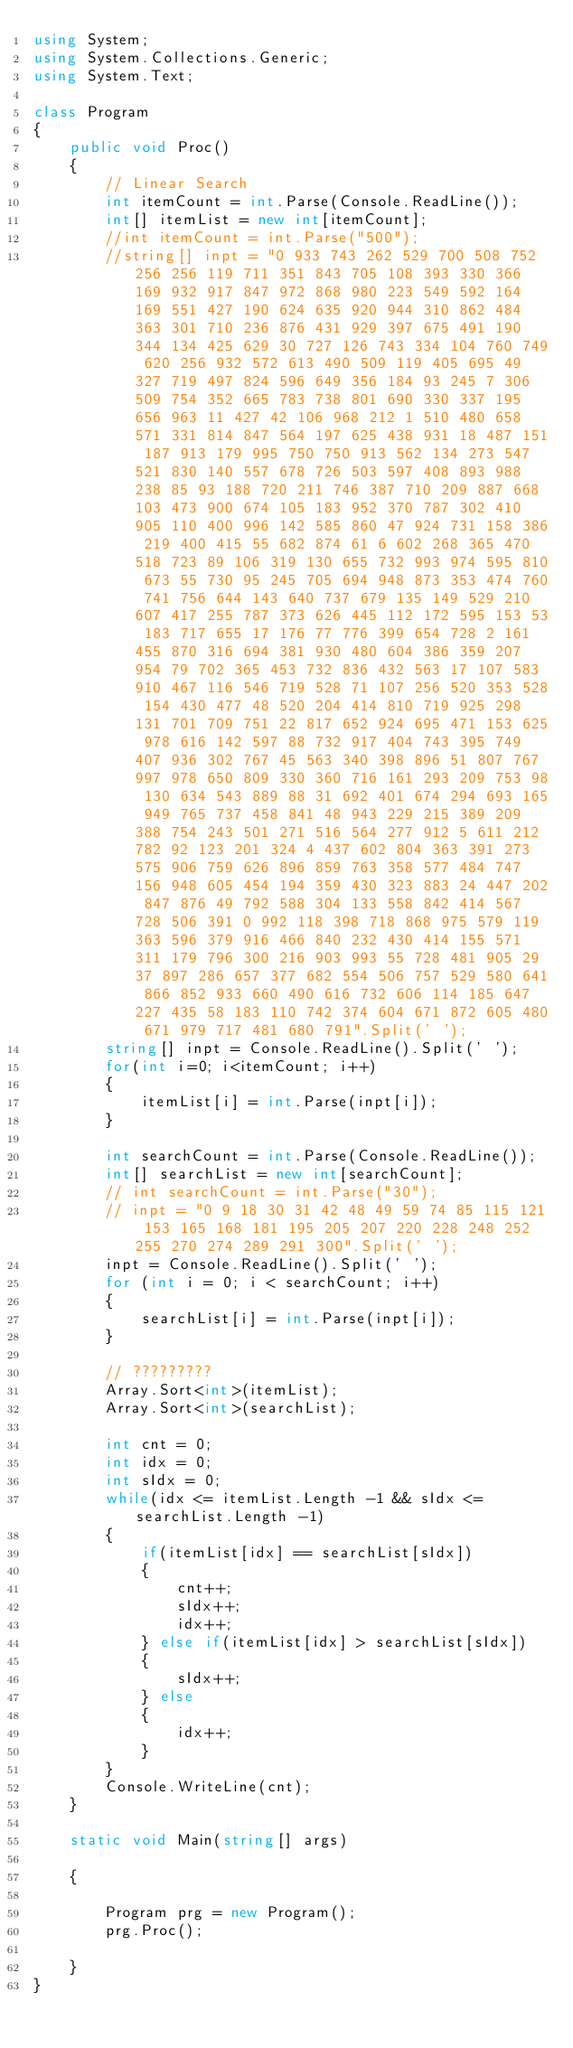Convert code to text. <code><loc_0><loc_0><loc_500><loc_500><_C#_>using System;
using System.Collections.Generic;
using System.Text;

class Program
{
    public void Proc()
    {
        // Linear Search
        int itemCount = int.Parse(Console.ReadLine());
        int[] itemList = new int[itemCount];
        //int itemCount = int.Parse("500");
        //string[] inpt = "0 933 743 262 529 700 508 752 256 256 119 711 351 843 705 108 393 330 366 169 932 917 847 972 868 980 223 549 592 164 169 551 427 190 624 635 920 944 310 862 484 363 301 710 236 876 431 929 397 675 491 190 344 134 425 629 30 727 126 743 334 104 760 749 620 256 932 572 613 490 509 119 405 695 49 327 719 497 824 596 649 356 184 93 245 7 306 509 754 352 665 783 738 801 690 330 337 195 656 963 11 427 42 106 968 212 1 510 480 658 571 331 814 847 564 197 625 438 931 18 487 151 187 913 179 995 750 750 913 562 134 273 547 521 830 140 557 678 726 503 597 408 893 988 238 85 93 188 720 211 746 387 710 209 887 668 103 473 900 674 105 183 952 370 787 302 410 905 110 400 996 142 585 860 47 924 731 158 386 219 400 415 55 682 874 61 6 602 268 365 470 518 723 89 106 319 130 655 732 993 974 595 810 673 55 730 95 245 705 694 948 873 353 474 760 741 756 644 143 640 737 679 135 149 529 210 607 417 255 787 373 626 445 112 172 595 153 53 183 717 655 17 176 77 776 399 654 728 2 161 455 870 316 694 381 930 480 604 386 359 207 954 79 702 365 453 732 836 432 563 17 107 583 910 467 116 546 719 528 71 107 256 520 353 528 154 430 477 48 520 204 414 810 719 925 298 131 701 709 751 22 817 652 924 695 471 153 625 978 616 142 597 88 732 917 404 743 395 749 407 936 302 767 45 563 340 398 896 51 807 767 997 978 650 809 330 360 716 161 293 209 753 98 130 634 543 889 88 31 692 401 674 294 693 165 949 765 737 458 841 48 943 229 215 389 209 388 754 243 501 271 516 564 277 912 5 611 212 782 92 123 201 324 4 437 602 804 363 391 273 575 906 759 626 896 859 763 358 577 484 747 156 948 605 454 194 359 430 323 883 24 447 202 847 876 49 792 588 304 133 558 842 414 567 728 506 391 0 992 118 398 718 868 975 579 119 363 596 379 916 466 840 232 430 414 155 571 311 179 796 300 216 903 993 55 728 481 905 29 37 897 286 657 377 682 554 506 757 529 580 641 866 852 933 660 490 616 732 606 114 185 647 227 435 58 183 110 742 374 604 671 872 605 480 671 979 717 481 680 791".Split(' ');
        string[] inpt = Console.ReadLine().Split(' ');
        for(int i=0; i<itemCount; i++)
        {
            itemList[i] = int.Parse(inpt[i]);
        }

        int searchCount = int.Parse(Console.ReadLine());
        int[] searchList = new int[searchCount];
        // int searchCount = int.Parse("30");
        // inpt = "0 9 18 30 31 42 48 49 59 74 85 115 121 153 165 168 181 195 205 207 220 228 248 252 255 270 274 289 291 300".Split(' ');
        inpt = Console.ReadLine().Split(' ');
        for (int i = 0; i < searchCount; i++)
        {
            searchList[i] = int.Parse(inpt[i]);
        }

        // ?????????
        Array.Sort<int>(itemList);
        Array.Sort<int>(searchList);

        int cnt = 0;
        int idx = 0;
        int sIdx = 0;
        while(idx <= itemList.Length -1 && sIdx <= searchList.Length -1)
        {
            if(itemList[idx] == searchList[sIdx])
            {
                cnt++;
                sIdx++;
                idx++;
            } else if(itemList[idx] > searchList[sIdx])
            {
                sIdx++;
            } else
            {
                idx++;
            }
        }
        Console.WriteLine(cnt);
    }

    static void Main(string[] args)

    {

        Program prg = new Program();
        prg.Proc();

    }
}</code> 